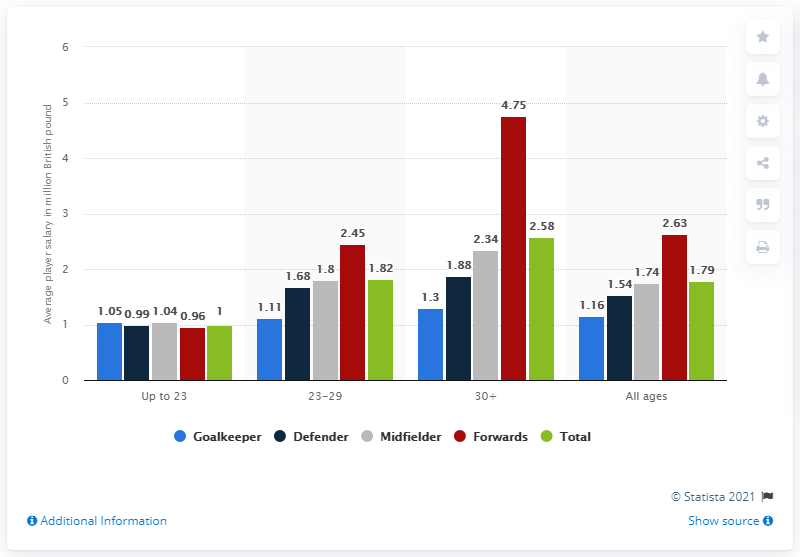Point out several critical features in this image. I would like to know the average salary for 23-29 and 30-plus year old players in the Serie A football league. It is expected that those aged 30 and older will receive higher salaries in the future. The sum of all the ages of the bars is 8.86.. The average under-23 player in the Serie A football league earns a yearly salary of approximately 1. 